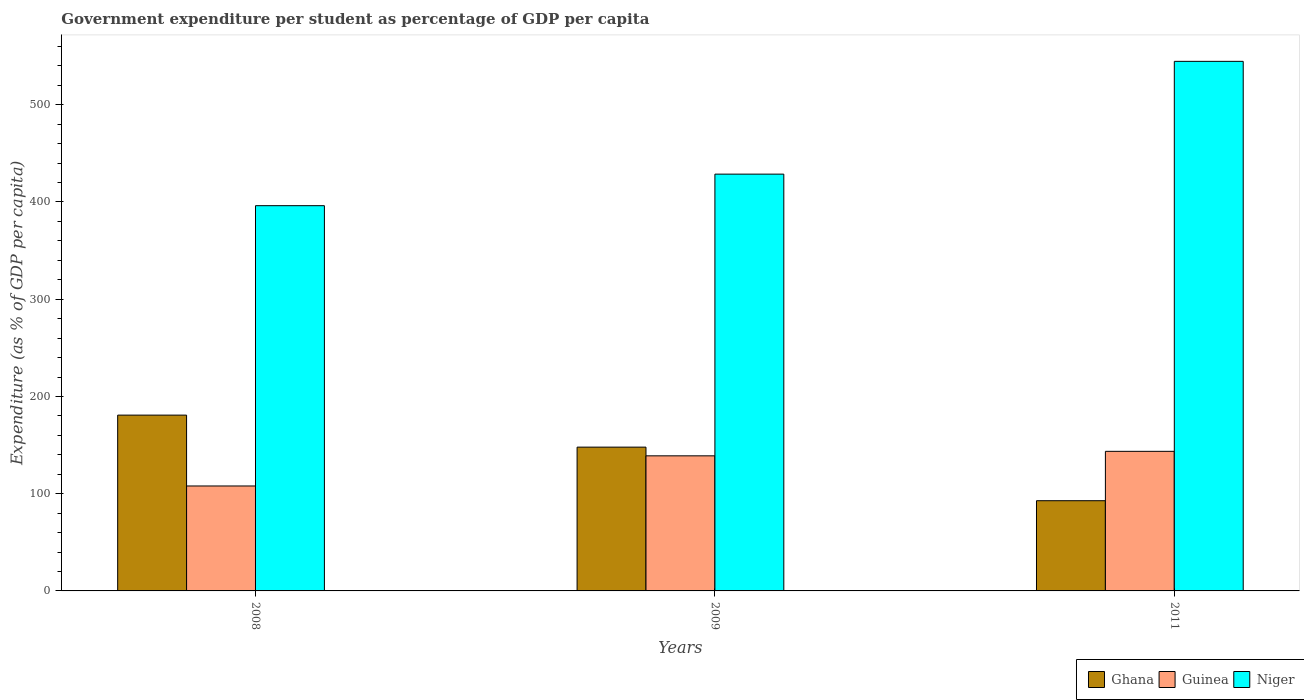How many groups of bars are there?
Provide a short and direct response. 3. What is the label of the 1st group of bars from the left?
Offer a very short reply. 2008. In how many cases, is the number of bars for a given year not equal to the number of legend labels?
Provide a short and direct response. 0. What is the percentage of expenditure per student in Niger in 2011?
Your answer should be compact. 544.64. Across all years, what is the maximum percentage of expenditure per student in Niger?
Provide a succinct answer. 544.64. Across all years, what is the minimum percentage of expenditure per student in Ghana?
Your response must be concise. 92.78. In which year was the percentage of expenditure per student in Niger minimum?
Keep it short and to the point. 2008. What is the total percentage of expenditure per student in Niger in the graph?
Offer a terse response. 1369.51. What is the difference between the percentage of expenditure per student in Ghana in 2009 and that in 2011?
Your answer should be very brief. 55.09. What is the difference between the percentage of expenditure per student in Guinea in 2008 and the percentage of expenditure per student in Ghana in 2011?
Provide a short and direct response. 15.14. What is the average percentage of expenditure per student in Ghana per year?
Your answer should be very brief. 140.49. In the year 2009, what is the difference between the percentage of expenditure per student in Guinea and percentage of expenditure per student in Ghana?
Offer a very short reply. -8.95. In how many years, is the percentage of expenditure per student in Niger greater than 240 %?
Your answer should be compact. 3. What is the ratio of the percentage of expenditure per student in Ghana in 2008 to that in 2009?
Your response must be concise. 1.22. Is the percentage of expenditure per student in Niger in 2008 less than that in 2009?
Provide a short and direct response. Yes. What is the difference between the highest and the second highest percentage of expenditure per student in Guinea?
Give a very brief answer. 4.63. What is the difference between the highest and the lowest percentage of expenditure per student in Niger?
Provide a succinct answer. 148.44. In how many years, is the percentage of expenditure per student in Niger greater than the average percentage of expenditure per student in Niger taken over all years?
Offer a very short reply. 1. Is the sum of the percentage of expenditure per student in Niger in 2009 and 2011 greater than the maximum percentage of expenditure per student in Ghana across all years?
Provide a succinct answer. Yes. What does the 1st bar from the left in 2008 represents?
Your response must be concise. Ghana. What does the 1st bar from the right in 2011 represents?
Make the answer very short. Niger. Are all the bars in the graph horizontal?
Your answer should be compact. No. What is the difference between two consecutive major ticks on the Y-axis?
Your answer should be compact. 100. Are the values on the major ticks of Y-axis written in scientific E-notation?
Your response must be concise. No. Where does the legend appear in the graph?
Provide a succinct answer. Bottom right. How many legend labels are there?
Make the answer very short. 3. How are the legend labels stacked?
Provide a succinct answer. Horizontal. What is the title of the graph?
Make the answer very short. Government expenditure per student as percentage of GDP per capita. What is the label or title of the Y-axis?
Your response must be concise. Expenditure (as % of GDP per capita). What is the Expenditure (as % of GDP per capita) of Ghana in 2008?
Ensure brevity in your answer.  180.8. What is the Expenditure (as % of GDP per capita) of Guinea in 2008?
Your response must be concise. 107.93. What is the Expenditure (as % of GDP per capita) in Niger in 2008?
Provide a succinct answer. 396.2. What is the Expenditure (as % of GDP per capita) of Ghana in 2009?
Ensure brevity in your answer.  147.88. What is the Expenditure (as % of GDP per capita) of Guinea in 2009?
Your response must be concise. 138.93. What is the Expenditure (as % of GDP per capita) in Niger in 2009?
Your answer should be compact. 428.66. What is the Expenditure (as % of GDP per capita) in Ghana in 2011?
Your answer should be very brief. 92.78. What is the Expenditure (as % of GDP per capita) of Guinea in 2011?
Keep it short and to the point. 143.56. What is the Expenditure (as % of GDP per capita) in Niger in 2011?
Provide a succinct answer. 544.64. Across all years, what is the maximum Expenditure (as % of GDP per capita) of Ghana?
Give a very brief answer. 180.8. Across all years, what is the maximum Expenditure (as % of GDP per capita) of Guinea?
Provide a succinct answer. 143.56. Across all years, what is the maximum Expenditure (as % of GDP per capita) in Niger?
Keep it short and to the point. 544.64. Across all years, what is the minimum Expenditure (as % of GDP per capita) of Ghana?
Keep it short and to the point. 92.78. Across all years, what is the minimum Expenditure (as % of GDP per capita) in Guinea?
Offer a terse response. 107.93. Across all years, what is the minimum Expenditure (as % of GDP per capita) in Niger?
Your answer should be compact. 396.2. What is the total Expenditure (as % of GDP per capita) of Ghana in the graph?
Ensure brevity in your answer.  421.47. What is the total Expenditure (as % of GDP per capita) of Guinea in the graph?
Your response must be concise. 390.42. What is the total Expenditure (as % of GDP per capita) in Niger in the graph?
Give a very brief answer. 1369.51. What is the difference between the Expenditure (as % of GDP per capita) of Ghana in 2008 and that in 2009?
Offer a terse response. 32.93. What is the difference between the Expenditure (as % of GDP per capita) in Guinea in 2008 and that in 2009?
Your answer should be very brief. -31.01. What is the difference between the Expenditure (as % of GDP per capita) in Niger in 2008 and that in 2009?
Make the answer very short. -32.45. What is the difference between the Expenditure (as % of GDP per capita) in Ghana in 2008 and that in 2011?
Offer a very short reply. 88.02. What is the difference between the Expenditure (as % of GDP per capita) of Guinea in 2008 and that in 2011?
Your response must be concise. -35.64. What is the difference between the Expenditure (as % of GDP per capita) of Niger in 2008 and that in 2011?
Ensure brevity in your answer.  -148.44. What is the difference between the Expenditure (as % of GDP per capita) in Ghana in 2009 and that in 2011?
Ensure brevity in your answer.  55.09. What is the difference between the Expenditure (as % of GDP per capita) of Guinea in 2009 and that in 2011?
Your answer should be compact. -4.63. What is the difference between the Expenditure (as % of GDP per capita) of Niger in 2009 and that in 2011?
Ensure brevity in your answer.  -115.99. What is the difference between the Expenditure (as % of GDP per capita) of Ghana in 2008 and the Expenditure (as % of GDP per capita) of Guinea in 2009?
Keep it short and to the point. 41.87. What is the difference between the Expenditure (as % of GDP per capita) in Ghana in 2008 and the Expenditure (as % of GDP per capita) in Niger in 2009?
Your answer should be compact. -247.85. What is the difference between the Expenditure (as % of GDP per capita) in Guinea in 2008 and the Expenditure (as % of GDP per capita) in Niger in 2009?
Make the answer very short. -320.73. What is the difference between the Expenditure (as % of GDP per capita) of Ghana in 2008 and the Expenditure (as % of GDP per capita) of Guinea in 2011?
Provide a short and direct response. 37.24. What is the difference between the Expenditure (as % of GDP per capita) of Ghana in 2008 and the Expenditure (as % of GDP per capita) of Niger in 2011?
Your response must be concise. -363.84. What is the difference between the Expenditure (as % of GDP per capita) of Guinea in 2008 and the Expenditure (as % of GDP per capita) of Niger in 2011?
Ensure brevity in your answer.  -436.72. What is the difference between the Expenditure (as % of GDP per capita) of Ghana in 2009 and the Expenditure (as % of GDP per capita) of Guinea in 2011?
Your response must be concise. 4.31. What is the difference between the Expenditure (as % of GDP per capita) of Ghana in 2009 and the Expenditure (as % of GDP per capita) of Niger in 2011?
Provide a short and direct response. -396.77. What is the difference between the Expenditure (as % of GDP per capita) in Guinea in 2009 and the Expenditure (as % of GDP per capita) in Niger in 2011?
Ensure brevity in your answer.  -405.71. What is the average Expenditure (as % of GDP per capita) in Ghana per year?
Your response must be concise. 140.49. What is the average Expenditure (as % of GDP per capita) in Guinea per year?
Your answer should be compact. 130.14. What is the average Expenditure (as % of GDP per capita) in Niger per year?
Your answer should be compact. 456.5. In the year 2008, what is the difference between the Expenditure (as % of GDP per capita) in Ghana and Expenditure (as % of GDP per capita) in Guinea?
Provide a short and direct response. 72.88. In the year 2008, what is the difference between the Expenditure (as % of GDP per capita) of Ghana and Expenditure (as % of GDP per capita) of Niger?
Offer a terse response. -215.4. In the year 2008, what is the difference between the Expenditure (as % of GDP per capita) of Guinea and Expenditure (as % of GDP per capita) of Niger?
Keep it short and to the point. -288.28. In the year 2009, what is the difference between the Expenditure (as % of GDP per capita) of Ghana and Expenditure (as % of GDP per capita) of Guinea?
Keep it short and to the point. 8.95. In the year 2009, what is the difference between the Expenditure (as % of GDP per capita) in Ghana and Expenditure (as % of GDP per capita) in Niger?
Keep it short and to the point. -280.78. In the year 2009, what is the difference between the Expenditure (as % of GDP per capita) of Guinea and Expenditure (as % of GDP per capita) of Niger?
Offer a very short reply. -289.73. In the year 2011, what is the difference between the Expenditure (as % of GDP per capita) of Ghana and Expenditure (as % of GDP per capita) of Guinea?
Provide a short and direct response. -50.78. In the year 2011, what is the difference between the Expenditure (as % of GDP per capita) in Ghana and Expenditure (as % of GDP per capita) in Niger?
Offer a very short reply. -451.86. In the year 2011, what is the difference between the Expenditure (as % of GDP per capita) of Guinea and Expenditure (as % of GDP per capita) of Niger?
Your answer should be compact. -401.08. What is the ratio of the Expenditure (as % of GDP per capita) of Ghana in 2008 to that in 2009?
Provide a succinct answer. 1.22. What is the ratio of the Expenditure (as % of GDP per capita) in Guinea in 2008 to that in 2009?
Your answer should be very brief. 0.78. What is the ratio of the Expenditure (as % of GDP per capita) in Niger in 2008 to that in 2009?
Give a very brief answer. 0.92. What is the ratio of the Expenditure (as % of GDP per capita) in Ghana in 2008 to that in 2011?
Give a very brief answer. 1.95. What is the ratio of the Expenditure (as % of GDP per capita) in Guinea in 2008 to that in 2011?
Give a very brief answer. 0.75. What is the ratio of the Expenditure (as % of GDP per capita) in Niger in 2008 to that in 2011?
Your answer should be very brief. 0.73. What is the ratio of the Expenditure (as % of GDP per capita) of Ghana in 2009 to that in 2011?
Make the answer very short. 1.59. What is the ratio of the Expenditure (as % of GDP per capita) of Guinea in 2009 to that in 2011?
Give a very brief answer. 0.97. What is the ratio of the Expenditure (as % of GDP per capita) of Niger in 2009 to that in 2011?
Keep it short and to the point. 0.79. What is the difference between the highest and the second highest Expenditure (as % of GDP per capita) in Ghana?
Your answer should be compact. 32.93. What is the difference between the highest and the second highest Expenditure (as % of GDP per capita) in Guinea?
Your answer should be compact. 4.63. What is the difference between the highest and the second highest Expenditure (as % of GDP per capita) of Niger?
Your answer should be compact. 115.99. What is the difference between the highest and the lowest Expenditure (as % of GDP per capita) in Ghana?
Provide a short and direct response. 88.02. What is the difference between the highest and the lowest Expenditure (as % of GDP per capita) in Guinea?
Keep it short and to the point. 35.64. What is the difference between the highest and the lowest Expenditure (as % of GDP per capita) in Niger?
Make the answer very short. 148.44. 